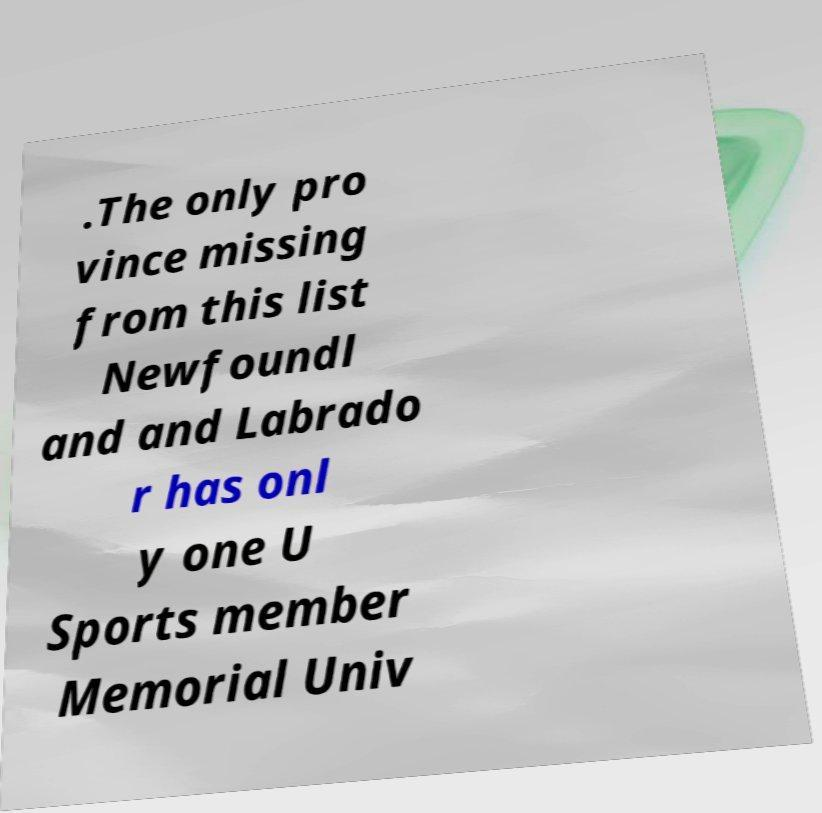There's text embedded in this image that I need extracted. Can you transcribe it verbatim? .The only pro vince missing from this list Newfoundl and and Labrado r has onl y one U Sports member Memorial Univ 